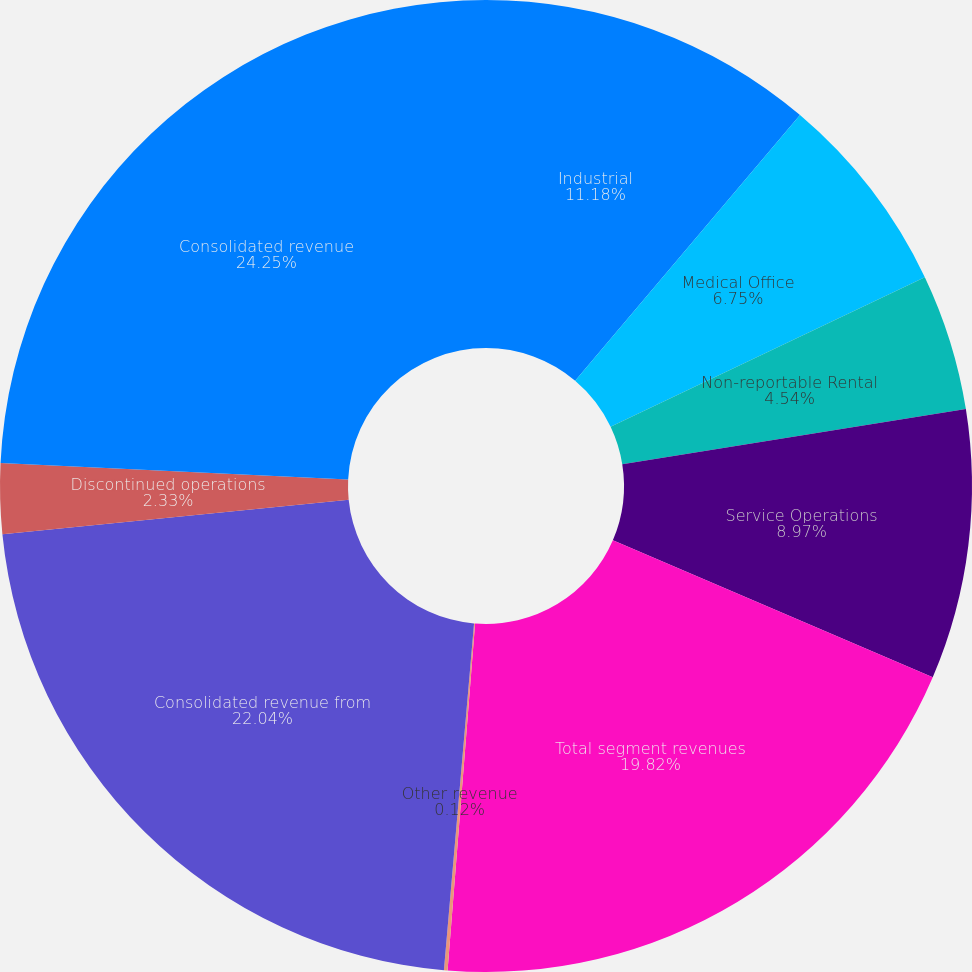<chart> <loc_0><loc_0><loc_500><loc_500><pie_chart><fcel>Industrial<fcel>Medical Office<fcel>Non-reportable Rental<fcel>Service Operations<fcel>Total segment revenues<fcel>Other revenue<fcel>Consolidated revenue from<fcel>Discontinued operations<fcel>Consolidated revenue<nl><fcel>11.18%<fcel>6.75%<fcel>4.54%<fcel>8.97%<fcel>19.82%<fcel>0.12%<fcel>22.04%<fcel>2.33%<fcel>24.25%<nl></chart> 